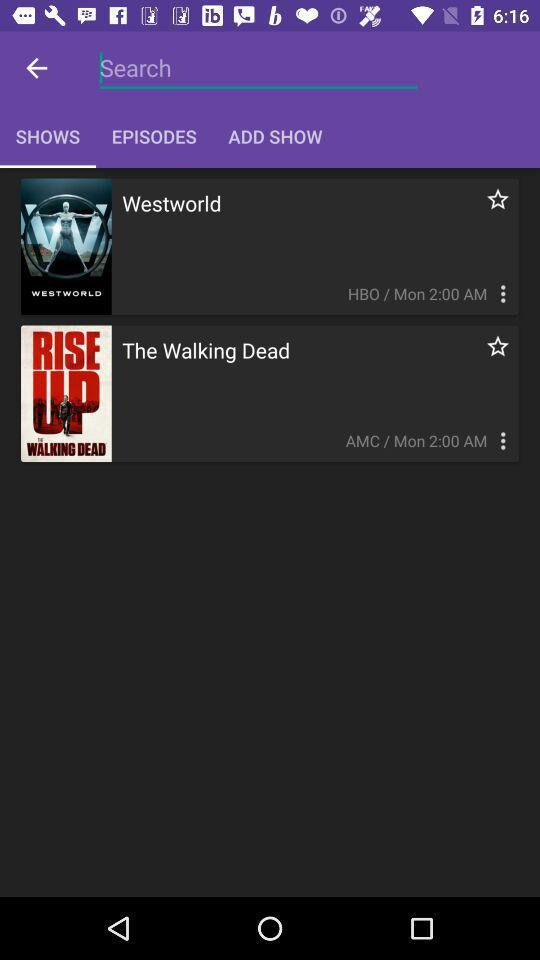What show is broadcast on the HBO channel? The show is "Westworld". 